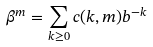Convert formula to latex. <formula><loc_0><loc_0><loc_500><loc_500>\beta ^ { m } = \sum _ { k \geq 0 } c ( k , m ) b ^ { - k }</formula> 